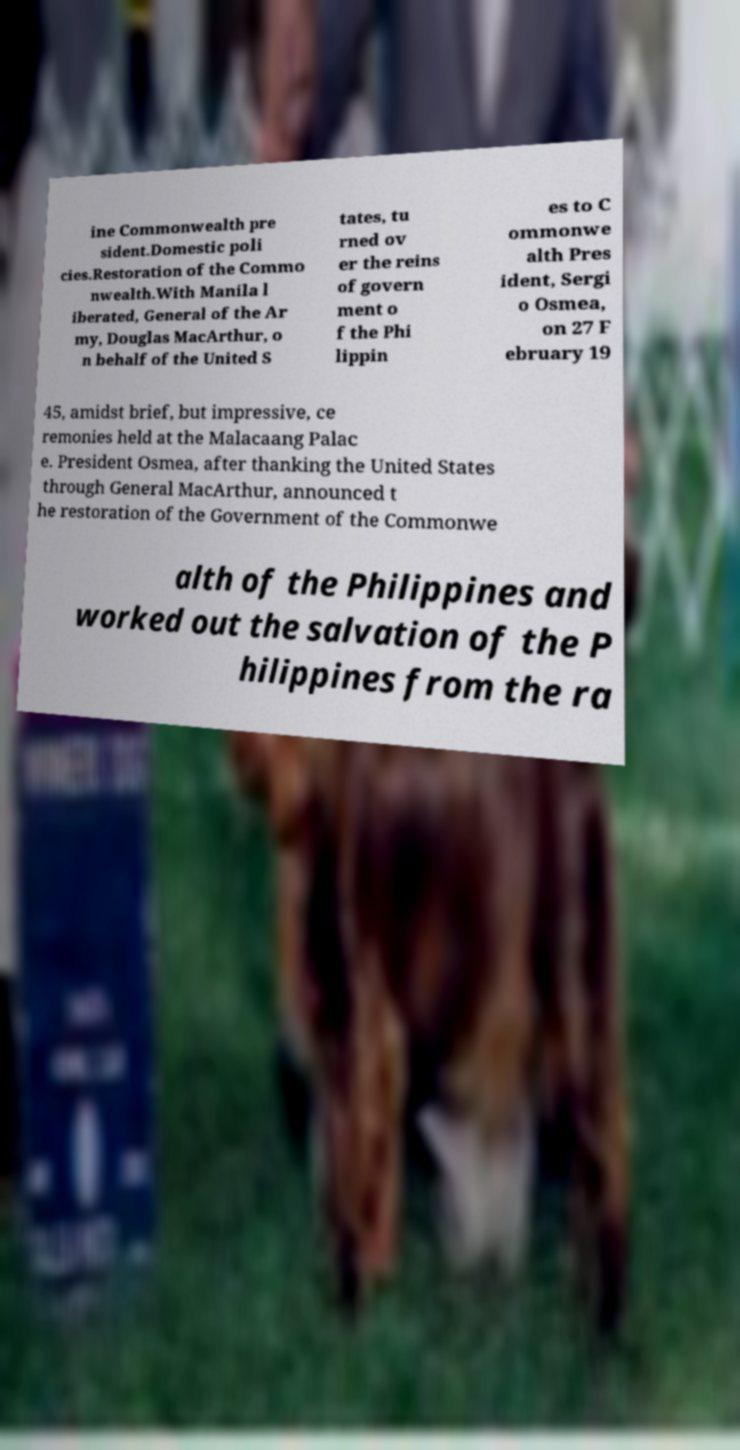Can you accurately transcribe the text from the provided image for me? ine Commonwealth pre sident.Domestic poli cies.Restoration of the Commo nwealth.With Manila l iberated, General of the Ar my, Douglas MacArthur, o n behalf of the United S tates, tu rned ov er the reins of govern ment o f the Phi lippin es to C ommonwe alth Pres ident, Sergi o Osmea, on 27 F ebruary 19 45, amidst brief, but impressive, ce remonies held at the Malacaang Palac e. President Osmea, after thanking the United States through General MacArthur, announced t he restoration of the Government of the Commonwe alth of the Philippines and worked out the salvation of the P hilippines from the ra 